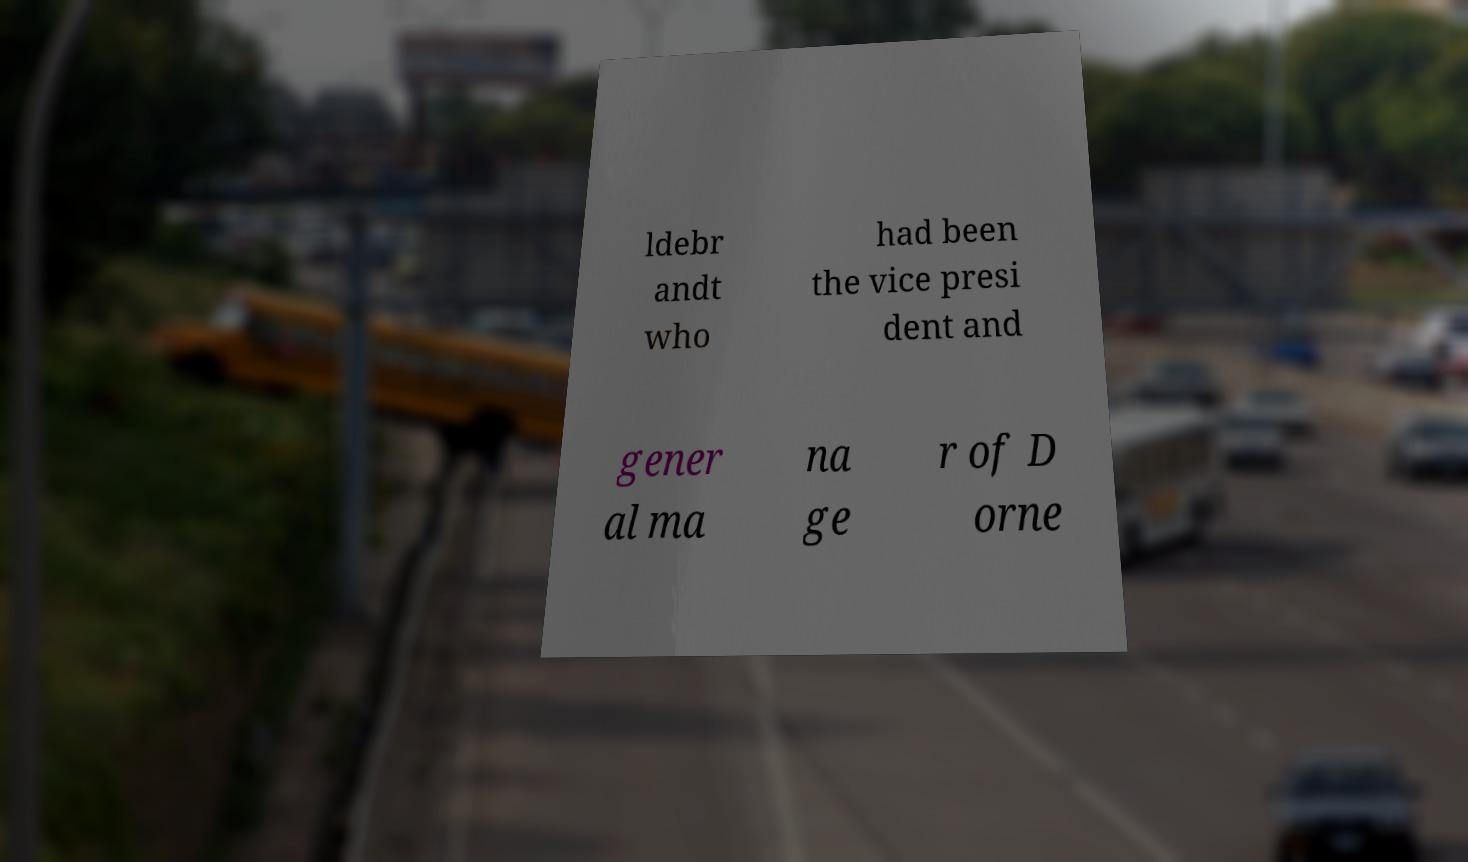For documentation purposes, I need the text within this image transcribed. Could you provide that? ldebr andt who had been the vice presi dent and gener al ma na ge r of D orne 